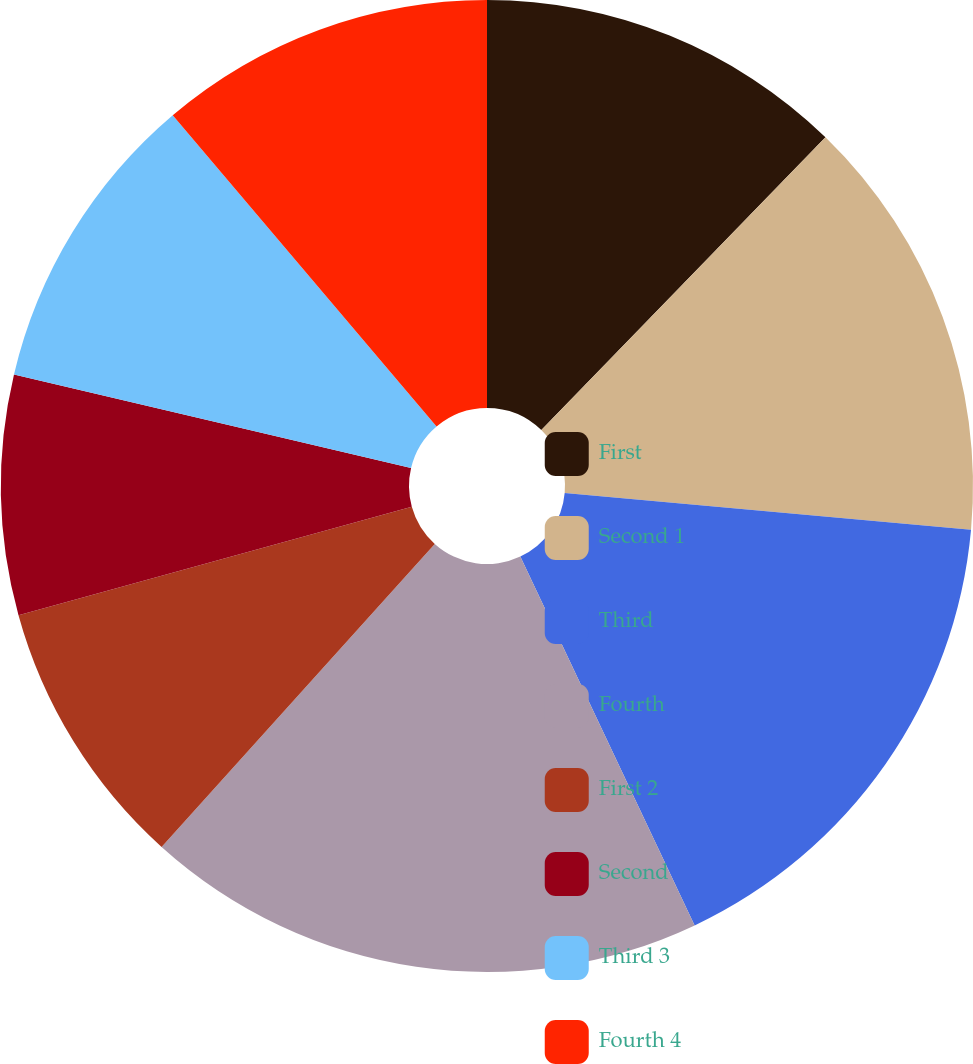Convert chart to OTSL. <chart><loc_0><loc_0><loc_500><loc_500><pie_chart><fcel>First<fcel>Second 1<fcel>Third<fcel>Fourth<fcel>First 2<fcel>Second<fcel>Third 3<fcel>Fourth 4<nl><fcel>12.26%<fcel>14.17%<fcel>16.54%<fcel>18.7%<fcel>9.04%<fcel>7.97%<fcel>10.12%<fcel>11.19%<nl></chart> 